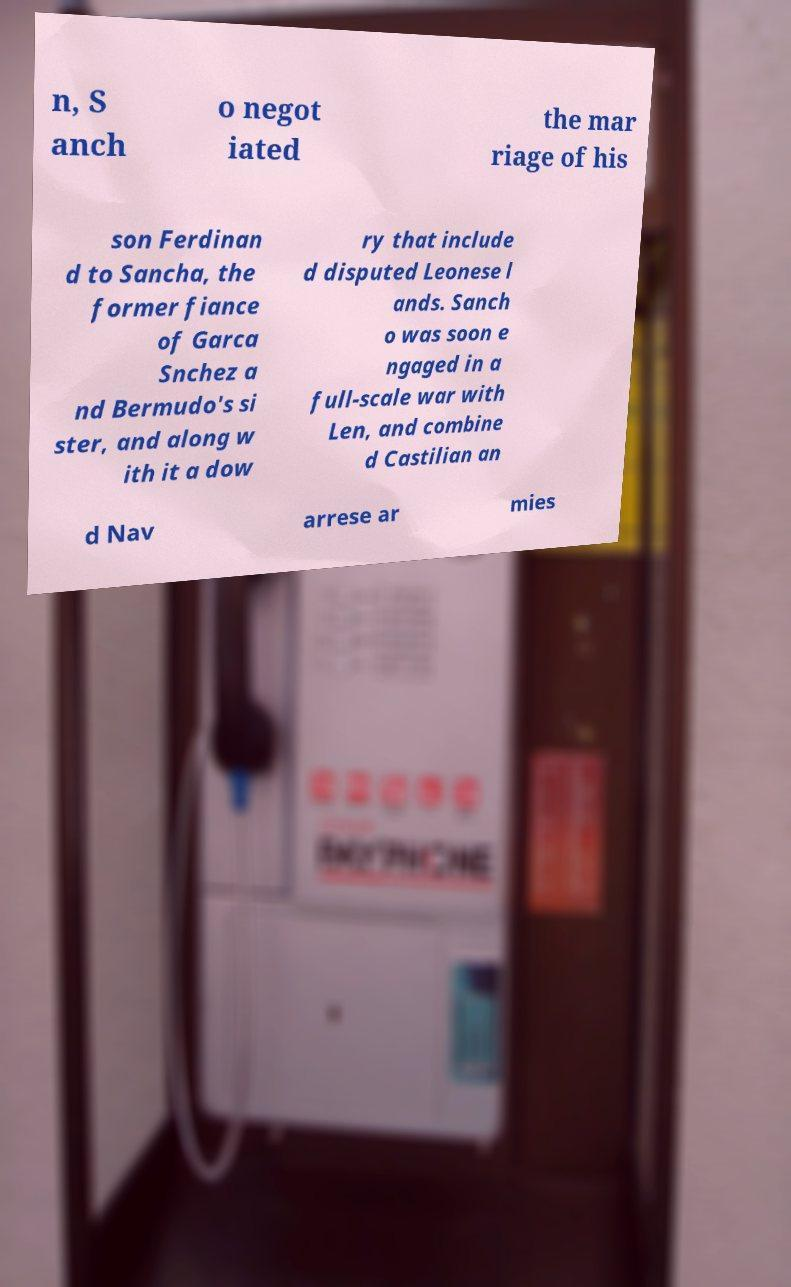I need the written content from this picture converted into text. Can you do that? n, S anch o negot iated the mar riage of his son Ferdinan d to Sancha, the former fiance of Garca Snchez a nd Bermudo's si ster, and along w ith it a dow ry that include d disputed Leonese l ands. Sanch o was soon e ngaged in a full-scale war with Len, and combine d Castilian an d Nav arrese ar mies 